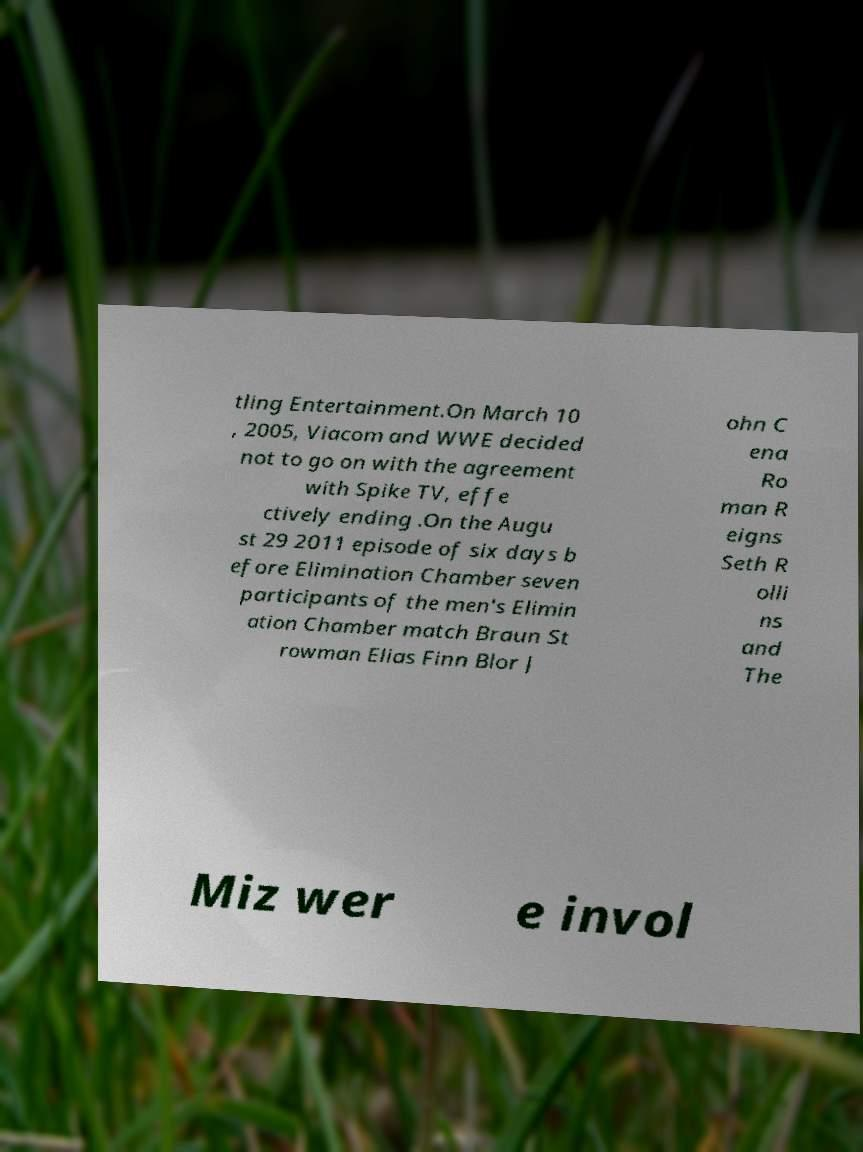Please identify and transcribe the text found in this image. tling Entertainment.On March 10 , 2005, Viacom and WWE decided not to go on with the agreement with Spike TV, effe ctively ending .On the Augu st 29 2011 episode of six days b efore Elimination Chamber seven participants of the men's Elimin ation Chamber match Braun St rowman Elias Finn Blor J ohn C ena Ro man R eigns Seth R olli ns and The Miz wer e invol 